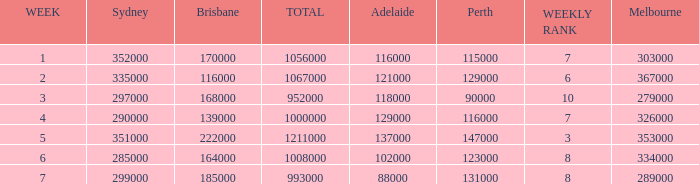How many viewers were there in Sydney for the episode when there were 334000 in Melbourne? 285000.0. Could you parse the entire table? {'header': ['WEEK', 'Sydney', 'Brisbane', 'TOTAL', 'Adelaide', 'Perth', 'WEEKLY RANK', 'Melbourne'], 'rows': [['1', '352000', '170000', '1056000', '116000', '115000', '7', '303000'], ['2', '335000', '116000', '1067000', '121000', '129000', '6', '367000'], ['3', '297000', '168000', '952000', '118000', '90000', '10', '279000'], ['4', '290000', '139000', '1000000', '129000', '116000', '7', '326000'], ['5', '351000', '222000', '1211000', '137000', '147000', '3', '353000'], ['6', '285000', '164000', '1008000', '102000', '123000', '8', '334000'], ['7', '299000', '185000', '993000', '88000', '131000', '8', '289000']]} 